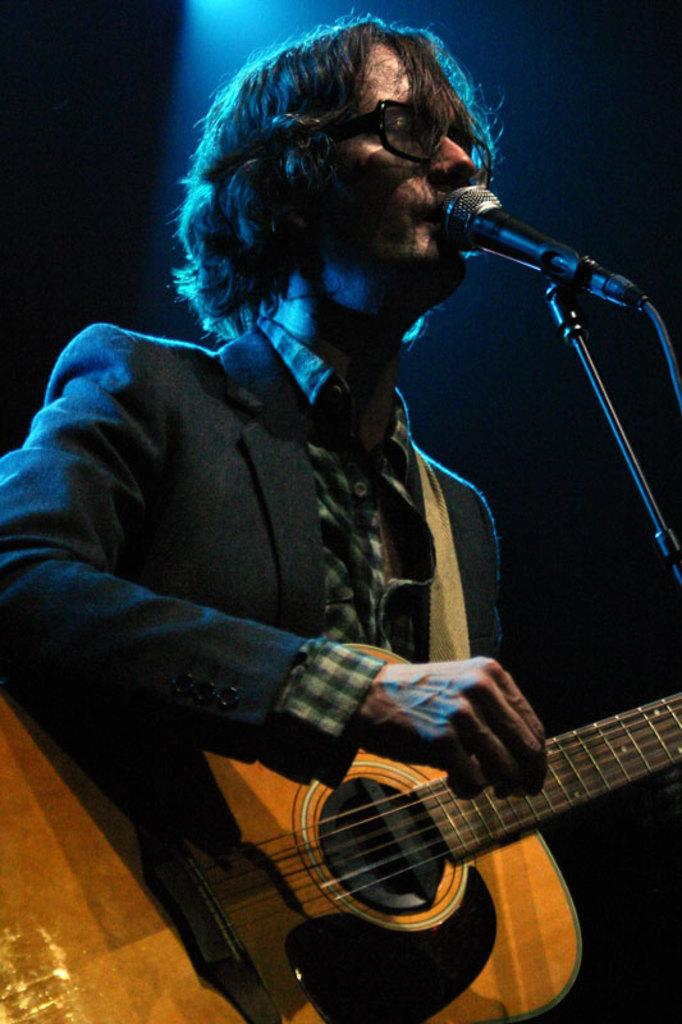What is the man in the image doing? The man is standing, playing a guitar, singing, and using a microphone. What instrument is the man playing in the image? The man is playing a guitar in the image. How is the man's voice being amplified in the image? The man is using a microphone to amplify his voice in the image. What type of twig is the man holding in the image? There is no twig present in the image; the man is holding a guitar. How does the man's heart rate change while singing in the image? The image does not provide information about the man's heart rate, so it cannot be determined from the image. 